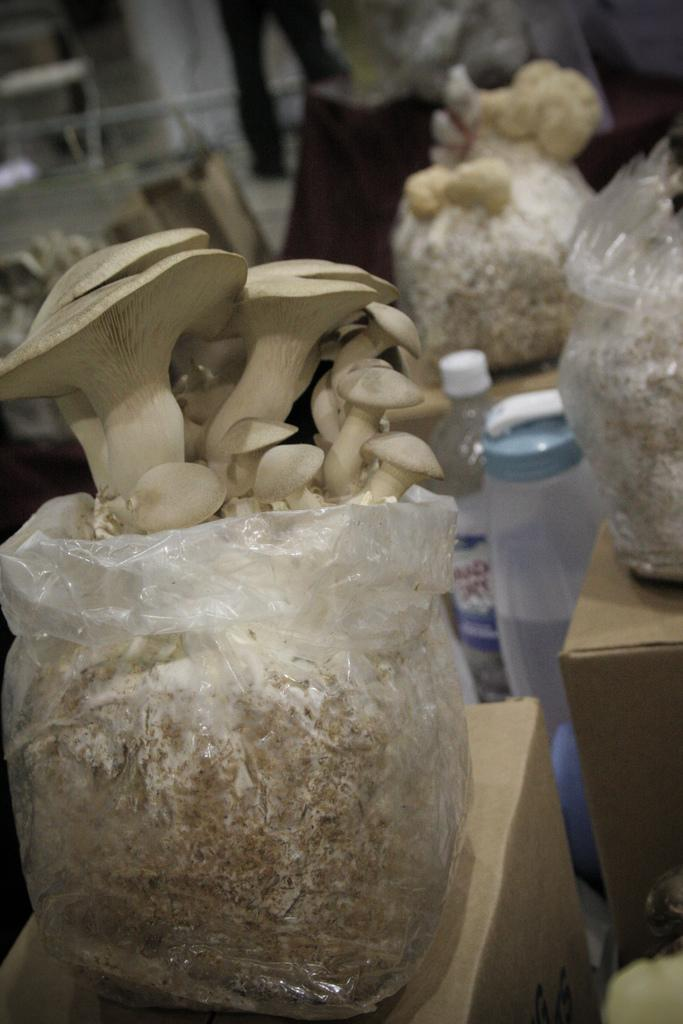What is inside the covers that are placed on card boxes? There are mushrooms in the covers. What are the covers placed on? The covers are placed on card boxes. How many bottles can be seen in the image? There are two bottles in the image. Can you describe the background of the image? There are objects in the background of the image. Is there a cannon visible in the image? No, there is no cannon present in the image. Can you see a rat hiding among the mushrooms in the covers? No, there is no rat present in the image. 